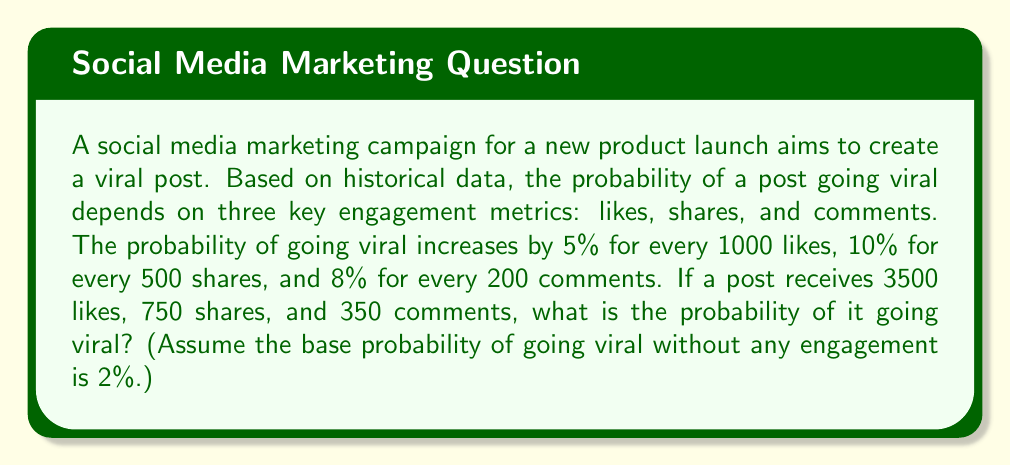Help me with this question. Let's break this down step-by-step:

1) First, let's calculate the increase in probability for each metric:

   Likes: $\frac{3500}{1000} \times 5\% = 17.5\%$
   Shares: $\frac{750}{500} \times 10\% = 15\%$
   Comments: $\frac{350}{200} \times 8\% = 14\%$

2) Now, we sum these probabilities and add the base probability:

   $P(\text{viral}) = 2\% + 17.5\% + 15\% + 14\%$

3) Simplifying:

   $P(\text{viral}) = 48.5\% = 0.485$

4) However, probabilities cannot exceed 1 (or 100%). If our calculation results in a probability greater than 1, we need to cap it at 1.

   In this case, $0.485 < 1$, so our calculated probability is valid.

Therefore, the probability of the post going viral is 0.485 or 48.5%.

This problem demonstrates how engagement metrics can be used to estimate the likelihood of social media success, which is crucial for modern marketing strategies.
Answer: 0.485 